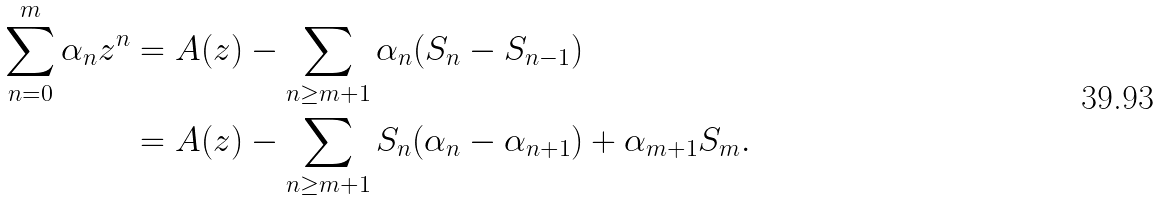Convert formula to latex. <formula><loc_0><loc_0><loc_500><loc_500>\sum _ { n = 0 } ^ { m } \alpha _ { n } z ^ { n } & = A ( z ) - \sum _ { n \geq m + 1 } \alpha _ { n } ( S _ { n } - S _ { n - 1 } ) \\ & = A ( z ) - \sum _ { n \geq m + 1 } S _ { n } ( \alpha _ { n } - \alpha _ { n + 1 } ) + \alpha _ { m + 1 } S _ { m } .</formula> 